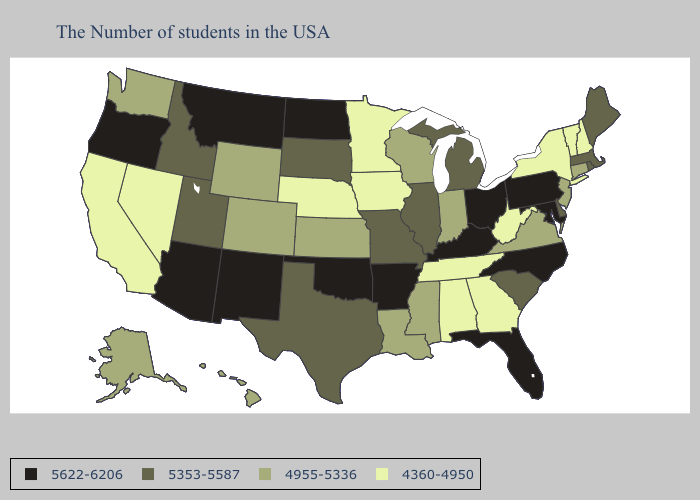What is the value of Alabama?
Be succinct. 4360-4950. Name the states that have a value in the range 5622-6206?
Write a very short answer. Maryland, Pennsylvania, North Carolina, Ohio, Florida, Kentucky, Arkansas, Oklahoma, North Dakota, New Mexico, Montana, Arizona, Oregon. Name the states that have a value in the range 5622-6206?
Give a very brief answer. Maryland, Pennsylvania, North Carolina, Ohio, Florida, Kentucky, Arkansas, Oklahoma, North Dakota, New Mexico, Montana, Arizona, Oregon. How many symbols are there in the legend?
Keep it brief. 4. What is the lowest value in the South?
Write a very short answer. 4360-4950. Does New York have the lowest value in the Northeast?
Quick response, please. Yes. Among the states that border Oklahoma , which have the lowest value?
Write a very short answer. Kansas, Colorado. Which states hav the highest value in the Northeast?
Keep it brief. Pennsylvania. Among the states that border California , does Arizona have the lowest value?
Write a very short answer. No. What is the lowest value in states that border Vermont?
Be succinct. 4360-4950. Name the states that have a value in the range 4955-5336?
Quick response, please. Connecticut, New Jersey, Virginia, Indiana, Wisconsin, Mississippi, Louisiana, Kansas, Wyoming, Colorado, Washington, Alaska, Hawaii. Does the first symbol in the legend represent the smallest category?
Short answer required. No. Name the states that have a value in the range 4360-4950?
Give a very brief answer. New Hampshire, Vermont, New York, West Virginia, Georgia, Alabama, Tennessee, Minnesota, Iowa, Nebraska, Nevada, California. What is the value of New York?
Write a very short answer. 4360-4950. Which states have the highest value in the USA?
Write a very short answer. Maryland, Pennsylvania, North Carolina, Ohio, Florida, Kentucky, Arkansas, Oklahoma, North Dakota, New Mexico, Montana, Arizona, Oregon. 